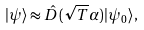<formula> <loc_0><loc_0><loc_500><loc_500>| \psi \rangle \approx \hat { D } ( \sqrt { T } \alpha ) | \psi _ { 0 } \rangle ,</formula> 